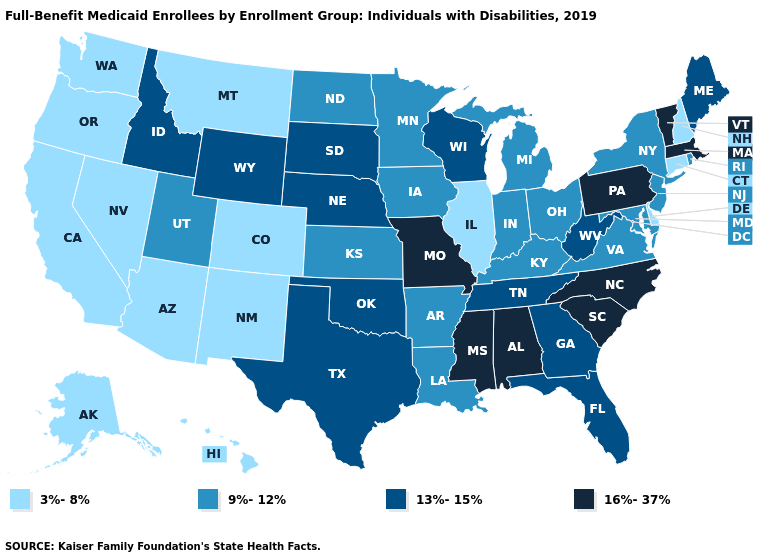Which states have the highest value in the USA?
Keep it brief. Alabama, Massachusetts, Mississippi, Missouri, North Carolina, Pennsylvania, South Carolina, Vermont. What is the value of Nebraska?
Be succinct. 13%-15%. Name the states that have a value in the range 3%-8%?
Be succinct. Alaska, Arizona, California, Colorado, Connecticut, Delaware, Hawaii, Illinois, Montana, Nevada, New Hampshire, New Mexico, Oregon, Washington. Among the states that border Iowa , which have the lowest value?
Concise answer only. Illinois. Does New Hampshire have a lower value than Wisconsin?
Be succinct. Yes. Does the first symbol in the legend represent the smallest category?
Short answer required. Yes. Which states have the highest value in the USA?
Keep it brief. Alabama, Massachusetts, Mississippi, Missouri, North Carolina, Pennsylvania, South Carolina, Vermont. What is the value of New Hampshire?
Be succinct. 3%-8%. What is the highest value in the Northeast ?
Write a very short answer. 16%-37%. Which states hav the highest value in the MidWest?
Quick response, please. Missouri. Name the states that have a value in the range 16%-37%?
Quick response, please. Alabama, Massachusetts, Mississippi, Missouri, North Carolina, Pennsylvania, South Carolina, Vermont. Does Vermont have the same value as Mississippi?
Write a very short answer. Yes. What is the highest value in the West ?
Keep it brief. 13%-15%. What is the highest value in the Northeast ?
Keep it brief. 16%-37%. Name the states that have a value in the range 13%-15%?
Be succinct. Florida, Georgia, Idaho, Maine, Nebraska, Oklahoma, South Dakota, Tennessee, Texas, West Virginia, Wisconsin, Wyoming. 